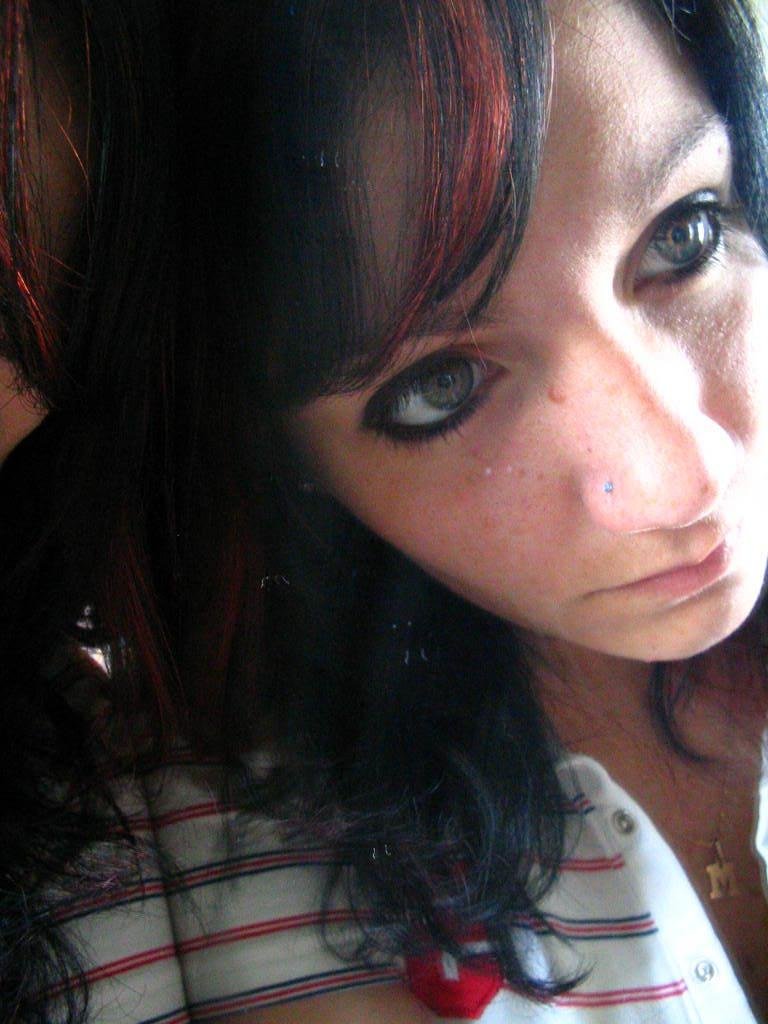What is the main subject of the image? The main subject of the image is a woman. Can you describe any accessories the woman is wearing? The woman is wearing a locket around her neck. What type of guitar is the woman playing in the image? There is no guitar present in the image; the woman is only wearing a locket. Can you recite the verse that the woman is saying in the image? There is no verse being said in the image; the woman is not depicted as speaking or reciting anything. 